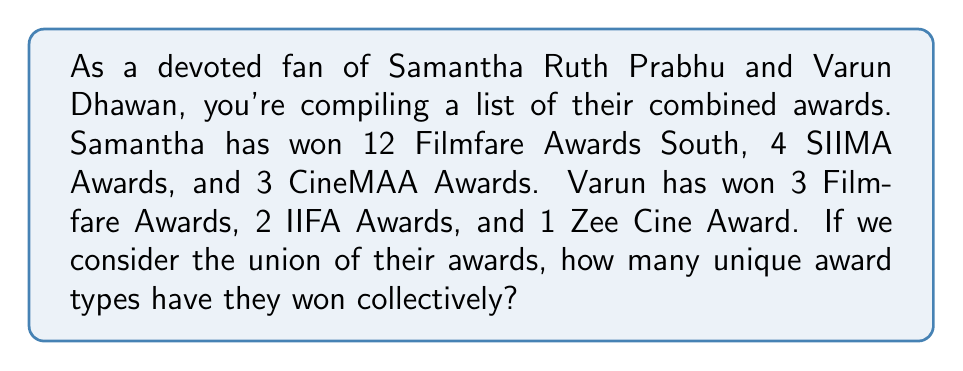Could you help me with this problem? To solve this problem, we need to use set theory, specifically the concept of union. Let's break it down step-by-step:

1. First, let's define our sets:
   Set A (Samantha's awards): {Filmfare Awards South, SIIMA Awards, CineMAA Awards}
   Set B (Varun's awards): {Filmfare Awards, IIFA Awards, Zee Cine Award}

2. The union of two sets A and B, denoted as $A \cup B$, is the set of all elements that are in A, or in B, or in both.

3. Let's list out all the unique award types:
   - Filmfare Awards South
   - SIIMA Awards
   - CineMAA Awards
   - Filmfare Awards
   - IIFA Awards
   - Zee Cine Award

4. Count the number of unique award types in this combined list.

5. The result is the cardinality of the union set, denoted as $|A \cup B|$.

Therefore, the number of unique award types they have won collectively is 6.
Answer: $|A \cup B| = 6$ 